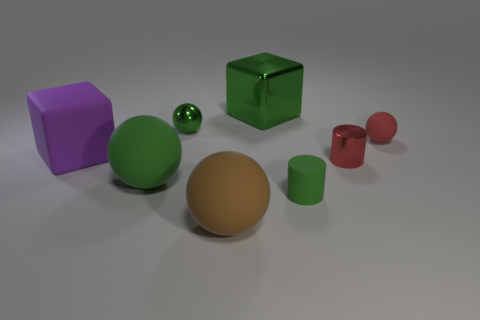Can you describe the lighting in the scene? The image has a soft, diffuse overhead lighting, which creates gentle shadows and highlights on the objects, giving the scene a calm and balanced appearance.  Is there anything suggesting the image is digitally created? The uniformity of the colors, the perfection of the objects' surfaces, and the precise shadows suggest that the image may have been rendered using 3D software rather than photographed in a physical setting. 